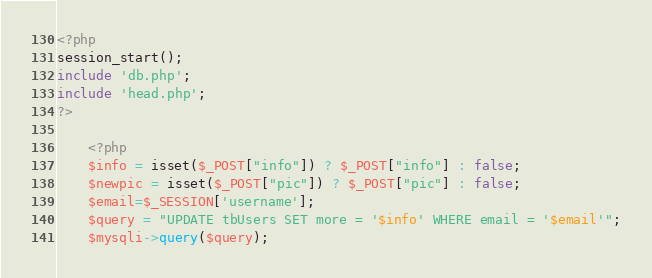<code> <loc_0><loc_0><loc_500><loc_500><_PHP_><?php
session_start();
include 'db.php';
include 'head.php';
?>

	<?php
	$info = isset($_POST["info"]) ? $_POST["info"] : false;
	$newpic = isset($_POST["pic"]) ? $_POST["pic"] : false;
	$email=$_SESSION['username'];
	$query = "UPDATE tbUsers SET more = '$info' WHERE email = '$email'";
	$mysqli->query($query);</code> 